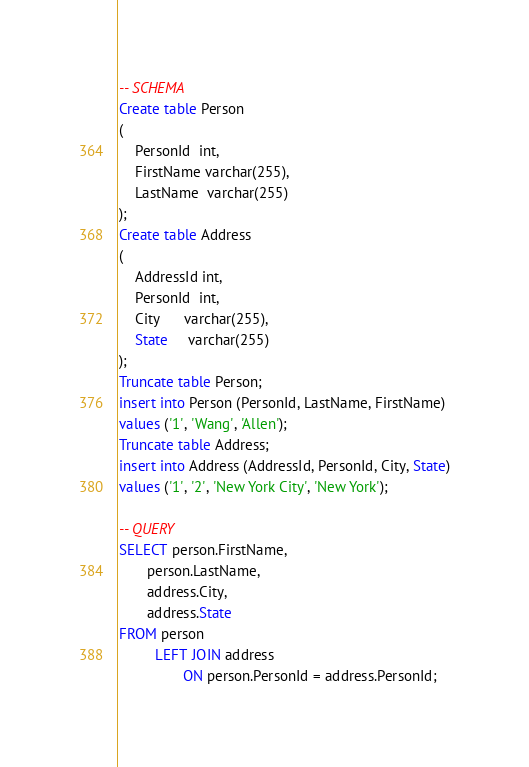<code> <loc_0><loc_0><loc_500><loc_500><_SQL_>-- SCHEMA
Create table Person
(
    PersonId  int,
    FirstName varchar(255),
    LastName  varchar(255)
);
Create table Address
(
    AddressId int,
    PersonId  int,
    City      varchar(255),
    State     varchar(255)
);
Truncate table Person;
insert into Person (PersonId, LastName, FirstName)
values ('1', 'Wang', 'Allen');
Truncate table Address;
insert into Address (AddressId, PersonId, City, State)
values ('1', '2', 'New York City', 'New York');

-- QUERY
SELECT person.FirstName,
       person.LastName,
       address.City,
       address.State
FROM person
         LEFT JOIN address
                ON person.PersonId = address.PersonId;</code> 